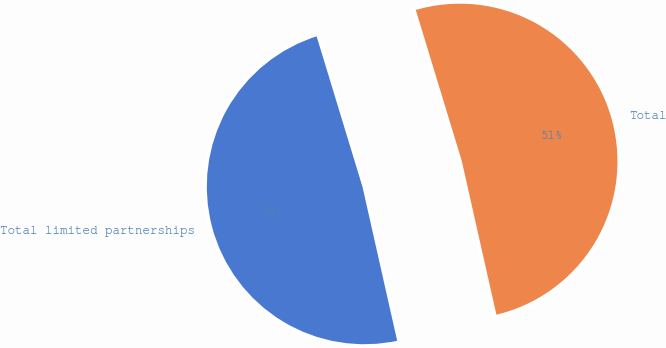<chart> <loc_0><loc_0><loc_500><loc_500><pie_chart><fcel>Total limited partnerships<fcel>Total<nl><fcel>48.82%<fcel>51.18%<nl></chart> 